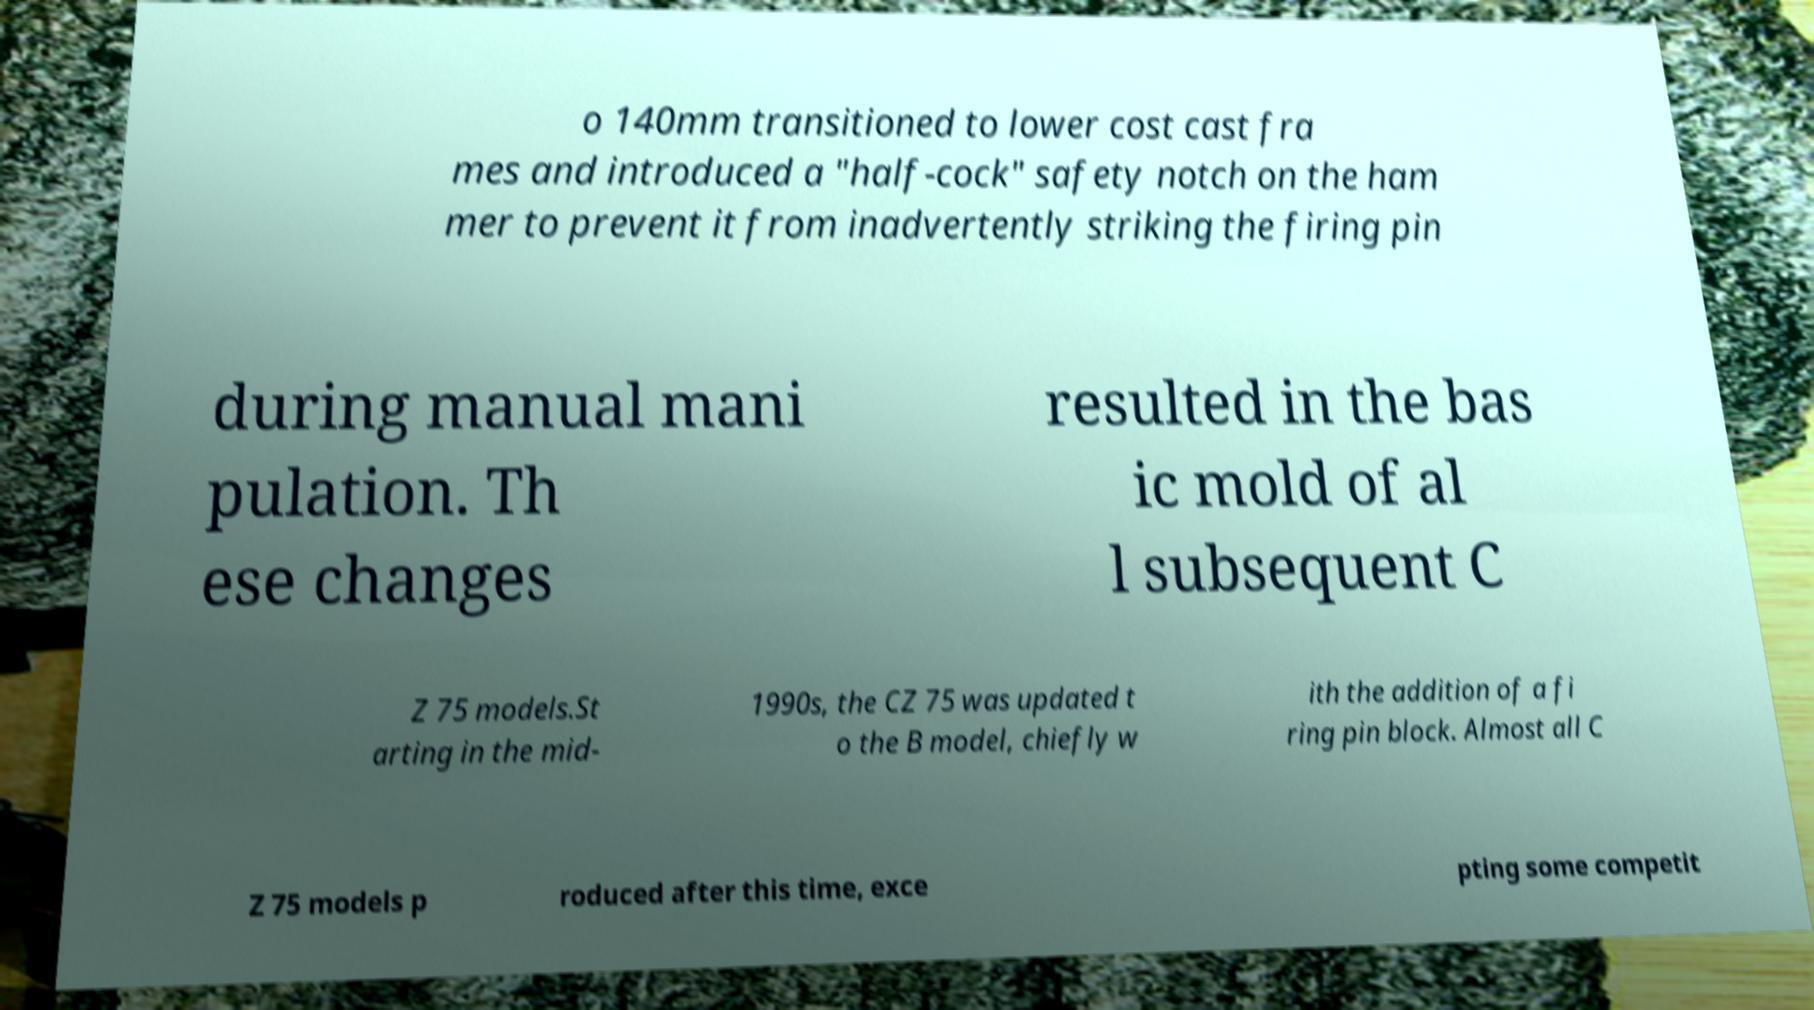Can you accurately transcribe the text from the provided image for me? o 140mm transitioned to lower cost cast fra mes and introduced a "half-cock" safety notch on the ham mer to prevent it from inadvertently striking the firing pin during manual mani pulation. Th ese changes resulted in the bas ic mold of al l subsequent C Z 75 models.St arting in the mid- 1990s, the CZ 75 was updated t o the B model, chiefly w ith the addition of a fi ring pin block. Almost all C Z 75 models p roduced after this time, exce pting some competit 